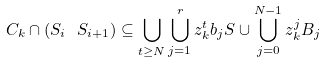<formula> <loc_0><loc_0><loc_500><loc_500>C _ { k } \cap ( S _ { i } \ S _ { i + 1 } ) \subseteq \bigcup _ { t \geq N } \bigcup _ { j = 1 } ^ { r } z _ { k } ^ { t } b _ { j } S \cup \bigcup _ { j = 0 } ^ { N - 1 } z _ { k } ^ { j } B _ { j }</formula> 